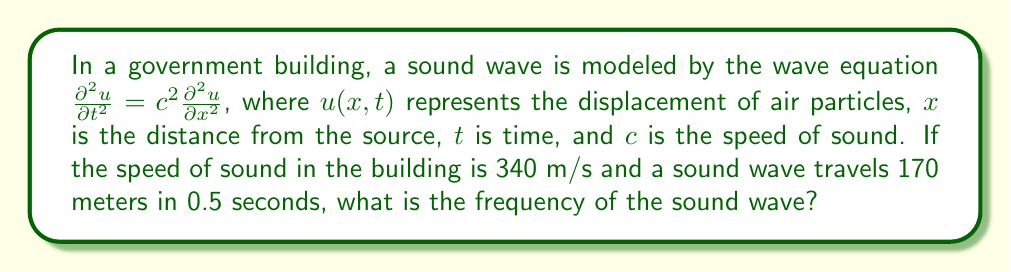Can you solve this math problem? To solve this problem, we'll follow these steps:

1) First, recall the wave equation for a sinusoidal wave:

   $$u(x,t) = A \sin(kx - \omega t)$$

   where $A$ is the amplitude, $k$ is the wave number, and $\omega$ is the angular frequency.

2) We know that $k = \frac{2\pi}{\lambda}$ and $\omega = 2\pi f$, where $\lambda$ is the wavelength and $f$ is the frequency.

3) We're given that the wave speed $c = 340$ m/s. We also know that $c = f\lambda$.

4) We can find $\lambda$ using the information that the wave travels 170 meters in 0.5 seconds:

   $$\lambda = 170 \text{ m} \cdot 2 = 340 \text{ m}$$

5) Now we can use the relation $c = f\lambda$ to find $f$:

   $$340 = f \cdot 340$$
   $$f = 1 \text{ Hz}$$

Therefore, the frequency of the sound wave is 1 Hz.
Answer: 1 Hz 